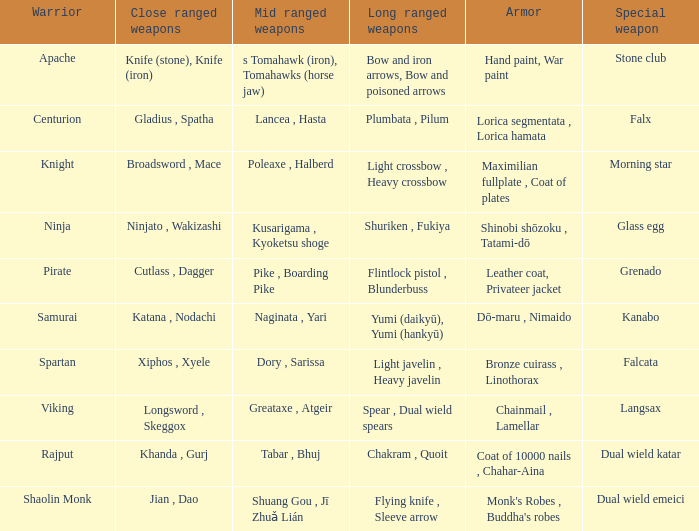If the body armor consists of bronze cuirass, linothorax, what are the short-distance weapons? Xiphos , Xyele. 